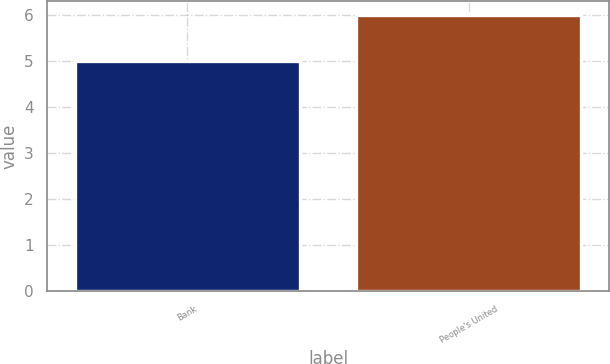Convert chart to OTSL. <chart><loc_0><loc_0><loc_500><loc_500><bar_chart><fcel>Bank<fcel>People's United<nl><fcel>5<fcel>6<nl></chart> 